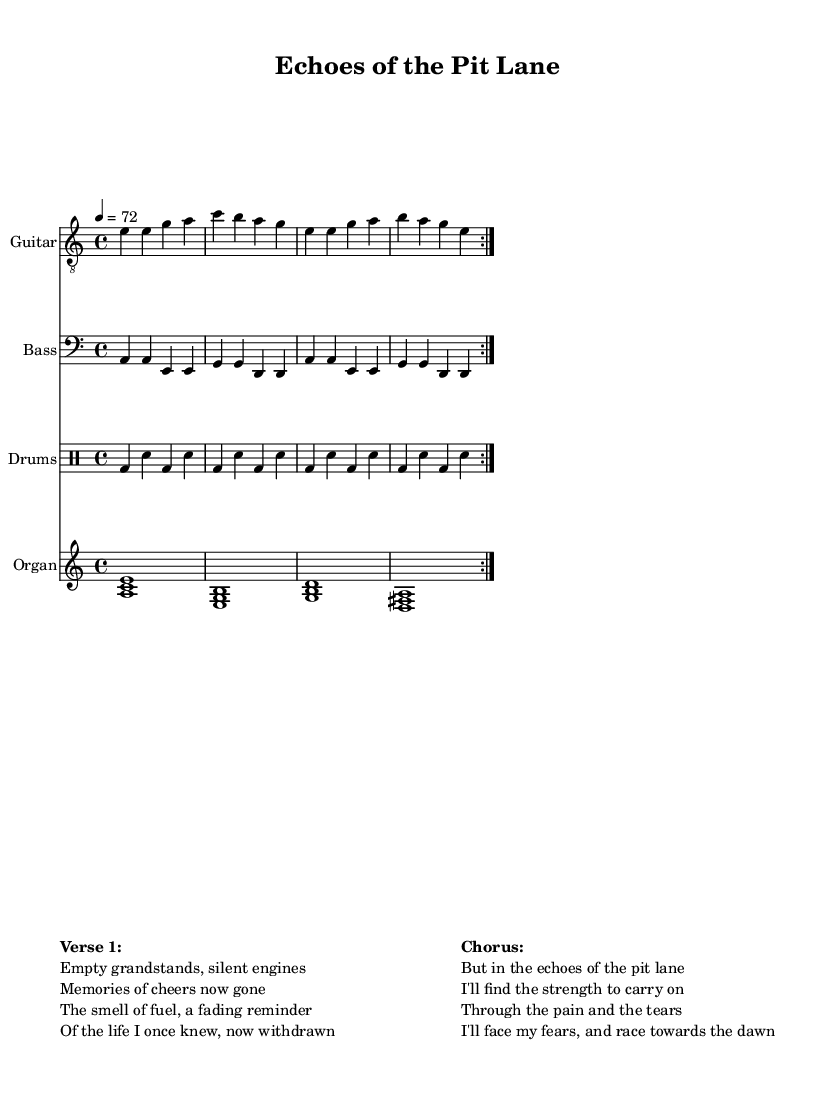What is the key signature of this music? The key signature is indicated by the number of sharps or flats at the beginning of the staff. In this piece, there are no sharps or flats shown next to the clef, which means it is either C major or A minor. The global context indicates that it is in A minor.
Answer: A minor What is the time signature of this music? The time signature is indicated by the two numbers at the beginning of the staff. Here, it shows 4/4, meaning there are four beats in each measure and the quarter note gets one beat.
Answer: 4/4 What is the tempo marking for this music? The tempo is marked at the beginning of the score, where it says “4 = 72”. This indicates that the quarter note corresponds to a beat of 72 beats per minute.
Answer: 72 How many measures are repeated in the guitar part? The repeat sign indicates that there are two measures being played multiple times. In the guitar section, the repeat volta appears, indicating that the section should be played twice.
Answer: 2 What themes are explored in the lyrics? The lyrics reflect themes of loss, nostalgia, and healing, as they discuss empty grandstands, memories, and finding strength in difficult times. The phrases relate closely to the emotions associated with grief and overcoming challenges.
Answer: Loss and healing What musical elements contribute to the blues-rock fusion style? The incorporation of electric guitar riffs, a steady rhythm section from the drums and bass, and soulful vocals reflect the blues-rock fusion style. Additionally, the introspective nature of the lyrics enhances the emotional depth typical of this genre.
Answer: Electric guitar riffs and soulful vocals What is the title of this piece? The title is clearly stated at the beginning of the score in the header section that reads "Echoes of the Pit Lane." This indicates the overall theme and emotional context of the music.
Answer: Echoes of the Pit Lane 